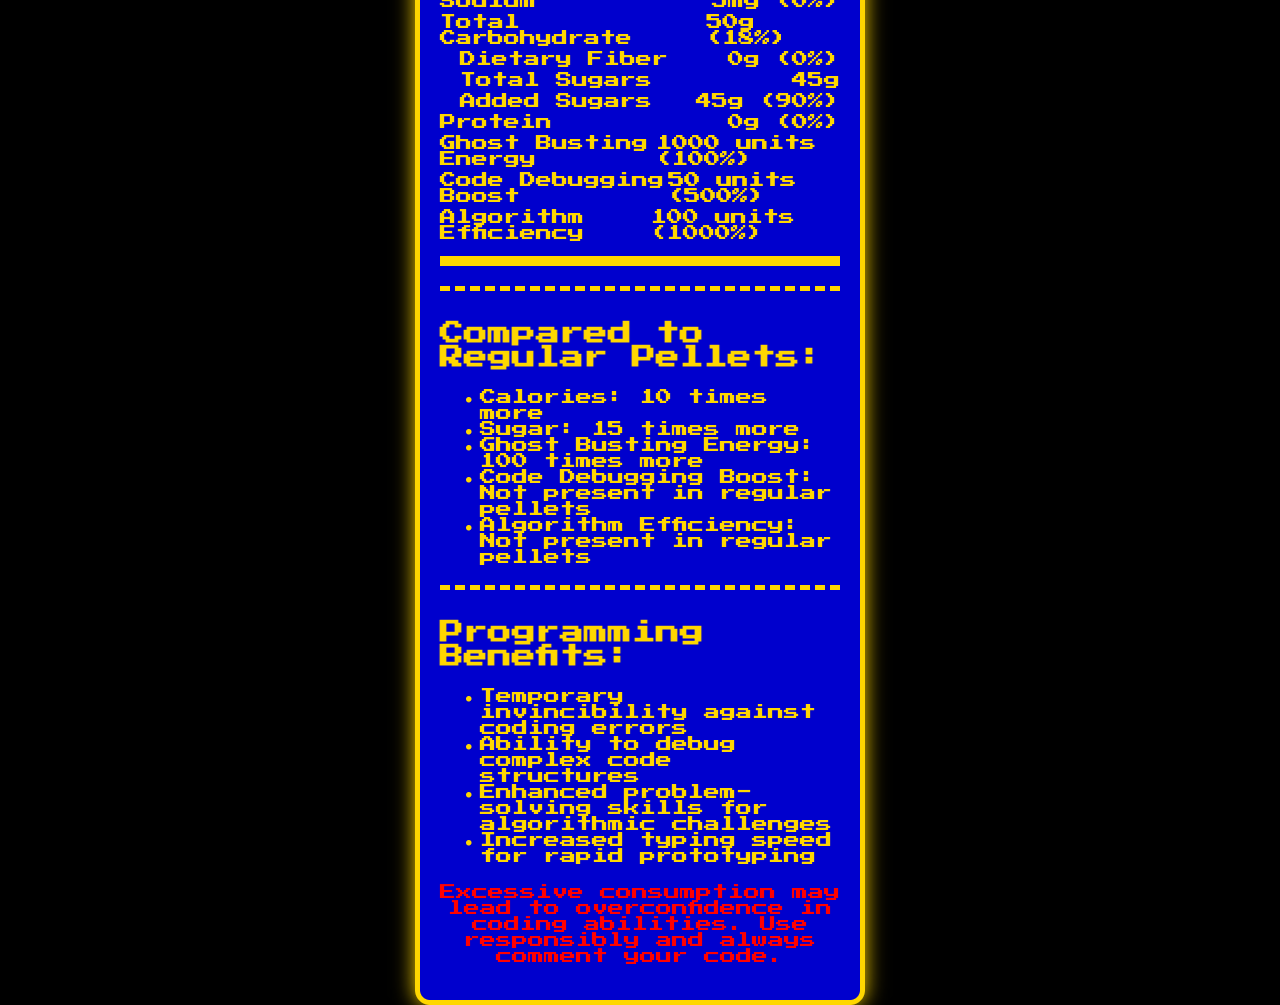what is the serving size for a Power Pellet? The serving size is listed directly in the document under "Serving Size".
Answer: 1 Power Pellet (10g) how many servings are in one container? The number of servings per container is clearly mentioned in the document as "Servings Per Container: 4".
Answer: 4 how many calories does one Power Pellet contain? The document specifies the calorie content under "Calories: 200".
Answer: 200 what is the amount of sodium in one serving of a Power Pellet? The sodium amount per serving is listed as "Sodium: 5mg".
Answer: 5mg does the Power Pellet contain any protein? The protein content is given as "Protein: 0g", hence there is no protein.
Answer: No which nutrient provides the most significant daily value percentage in a Power Pellet? A. Total Fat B. Added Sugars C. Sodium D. Dietary Fiber The document states that added sugars provide 90% of the daily value, which is the highest among the listed nutrients.
Answer: B how much ghost-busting energy does one Power Pellet provide? The document mentions "Ghost Busting Energy: 1000 units".
Answer: 1000 units what is the daily value percentage for Algorithm Efficiency in one Power Pellet? The document lists "Algorithm Efficiency" with a daily value of 1000%.
Answer: 1000% how much higher is the sugar content in a Power Pellet compared to regular pellets? The comparison section states that the sugar content is "15 times more" than in regular pellets.
Answer: 15 times more does consuming Power Pellets offer any benefits for programmers? The document lists multiple programming benefits such as temporary invincibility against coding errors and enhanced problem-solving skills for algorithmic challenges.
Answer: Yes summarize the main idea of the document. The main idea of the document is to inform about the nutritional facts and special benefits of Pac-Man Power Pellets, particularly emphasizing their use for programming tasks and their comparison with regular pellets.
Answer: The document provides detailed nutritional information about Pac-Man Power Pellets, including serving size, calorie content, and various nutrients. It compares these with regular pellets and highlights programming-related benefits and potential warnings. how many grams of dietary fiber are in one Power Pellet? The document indicates that dietary fiber content is "0g" per serving.
Answer: 0g does the Power Pellet contain Vitamin C? The document clearly states Vitamin C content is "0mg".
Answer: No what is the calorie content comparison between a Power Pellet and regular pellets? A. 5 times more B. 10 times more C. 15 times more D. 20 times more According to the comparison section, the Power Pellet has "10 times more" calories than regular pellets.
Answer: B does the Power Pellet offer any boost in coding abilities? The document lists enhancements like "Code Debugging Boost" and "Algorithm Efficiency" which specifically benefit coding abilities.
Answer: Yes which daily value percentage is not present in the regular pellets? A. Dietary Fiber B. Protein C. Code Debugging Boost D. Total Sugars The document states that "Code Debugging Boost" is not present in regular pellets.
Answer: C how can excessive consumption of Power Pellets affect coding abilities according to the document? The warning section states "Excessive consumption may lead to overconfidence in coding abilities."
Answer: May lead to overconfidence in coding abilities what is the responsibility of programmers when consuming Power Pellets? The warning advises to "always comment your code."
Answer: Comment their code how much potassium is in one Power Pellet? The document provides the potassium content as "10mg".
Answer: 10mg are there any vitamins present in one Power Pellet? The document specifies that Vitamin A and Vitamin C are both "0%", indicating no vitamins are present.
Answer: No what is the exact amount of Code Debugging Boost provided by one Power Pellet? The document clearly mentions "Code Debugging Boost: 50 units".
Answer: 50 units which enhancement is not mentioned in the document for the Power Pellets? The enhancement related to AI or machine learning performance is not discussed in the document, making the exact answer unattainable.
Answer: Not enough information is the daily value percentage for protein present in one Power Pellet significant? The daily value percentage for protein is "0%", indicating it is not significant.
Answer: No 